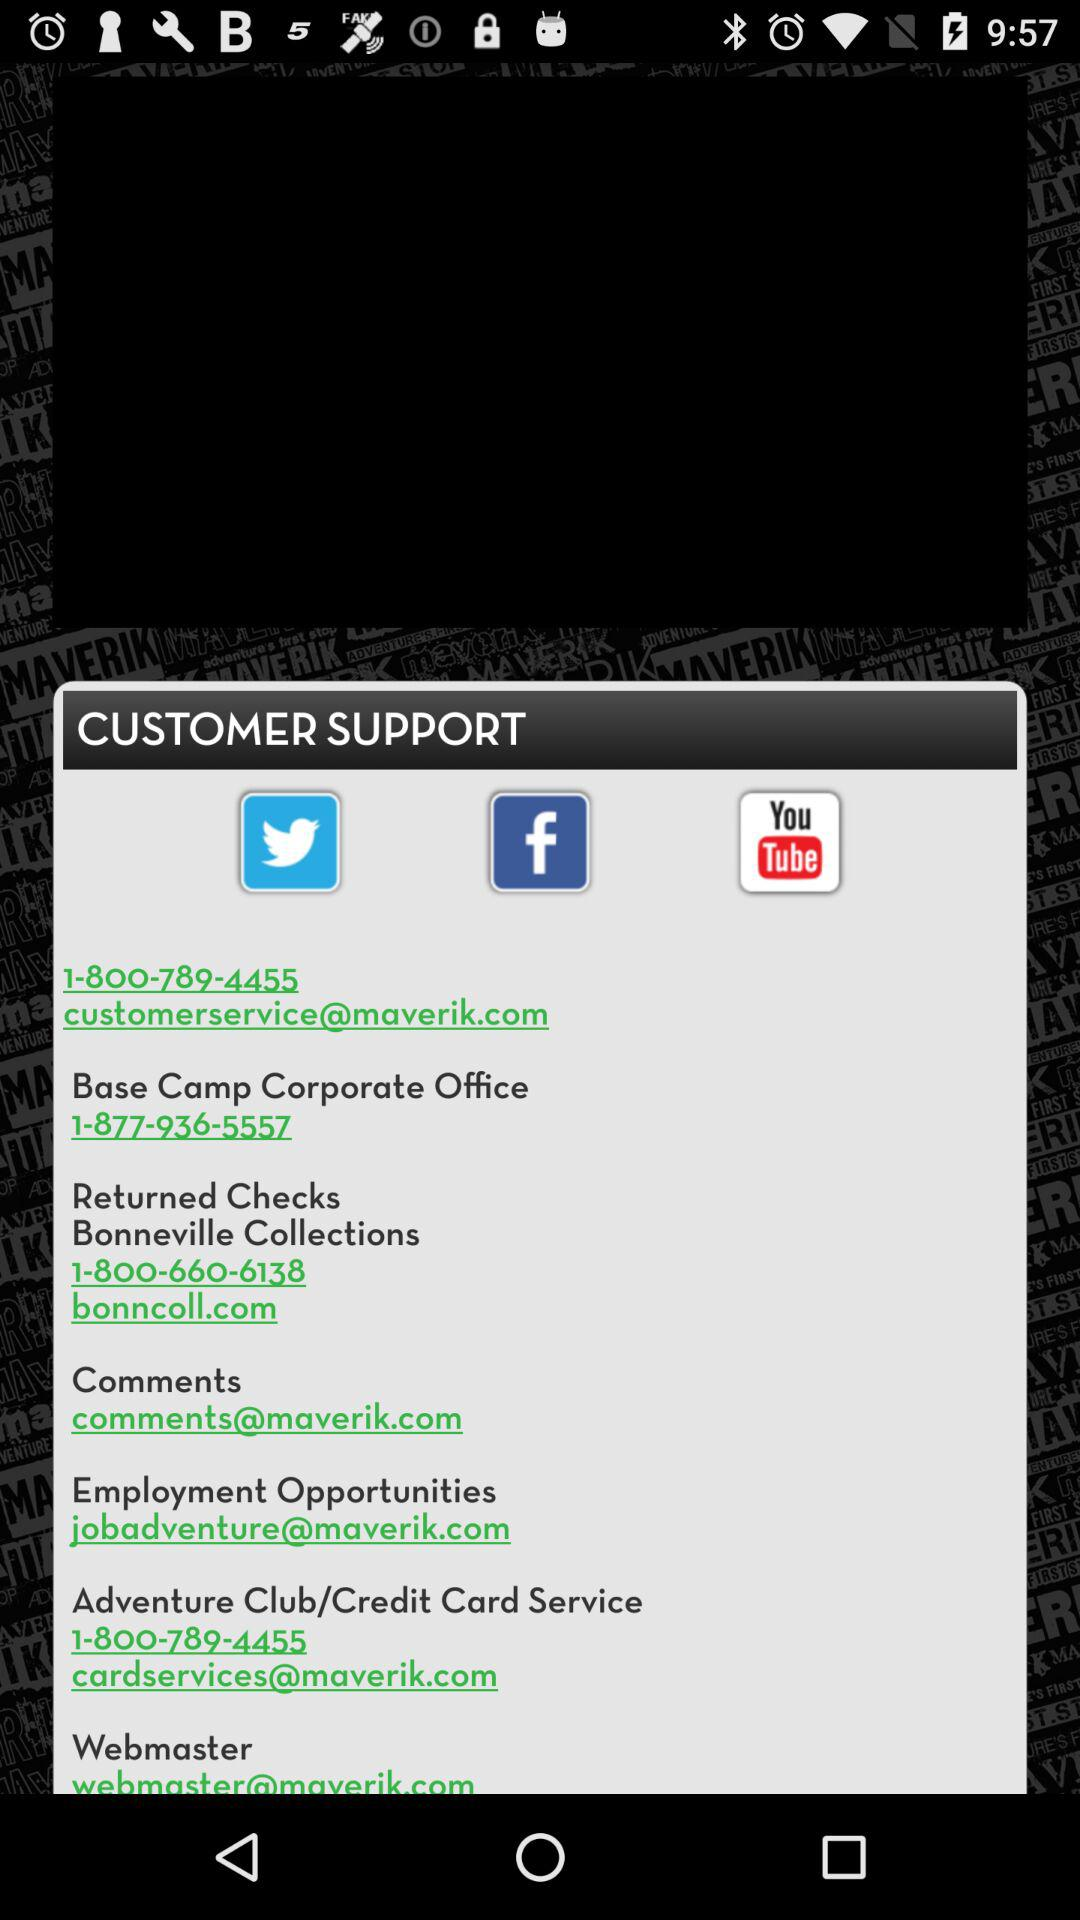What is the contact number for the Adventure Club? The contact number for the Adventure Club is 1-800-789-4455. 